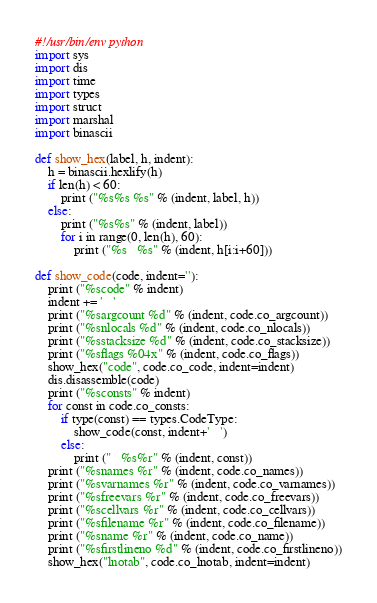<code> <loc_0><loc_0><loc_500><loc_500><_Python_>#!/usr/bin/env python
import sys
import dis
import time
import types
import struct
import marshal
import binascii

def show_hex(label, h, indent):
    h = binascii.hexlify(h)
    if len(h) < 60:
        print ("%s%s %s" % (indent, label, h))
    else:
        print ("%s%s" % (indent, label))
        for i in range(0, len(h), 60):
            print ("%s   %s" % (indent, h[i:i+60]))

def show_code(code, indent=''):
    print ("%scode" % indent)
    indent += '   '
    print ("%sargcount %d" % (indent, code.co_argcount))
    print ("%snlocals %d" % (indent, code.co_nlocals))
    print ("%sstacksize %d" % (indent, code.co_stacksize))
    print ("%sflags %04x" % (indent, code.co_flags))
    show_hex("code", code.co_code, indent=indent)
    dis.disassemble(code)
    print ("%sconsts" % indent)
    for const in code.co_consts:
        if type(const) == types.CodeType:
            show_code(const, indent+'   ')
        else:
            print ("   %s%r" % (indent, const))
    print ("%snames %r" % (indent, code.co_names))
    print ("%svarnames %r" % (indent, code.co_varnames))
    print ("%sfreevars %r" % (indent, code.co_freevars))
    print ("%scellvars %r" % (indent, code.co_cellvars))
    print ("%sfilename %r" % (indent, code.co_filename))
    print ("%sname %r" % (indent, code.co_name))
    print ("%sfirstlineno %d" % (indent, code.co_firstlineno))
    show_hex("lnotab", code.co_lnotab, indent=indent)
</code> 